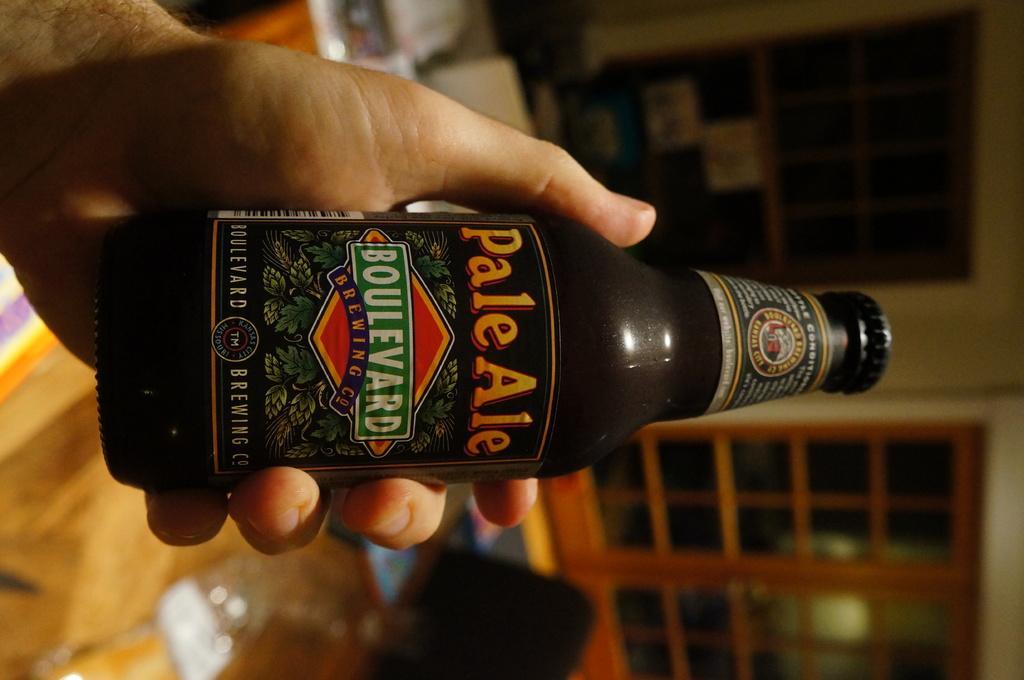How would you summarize this image in a sentence or two? In this image we can see a bottle which is of brand boulevard which is held by a person's hand. 